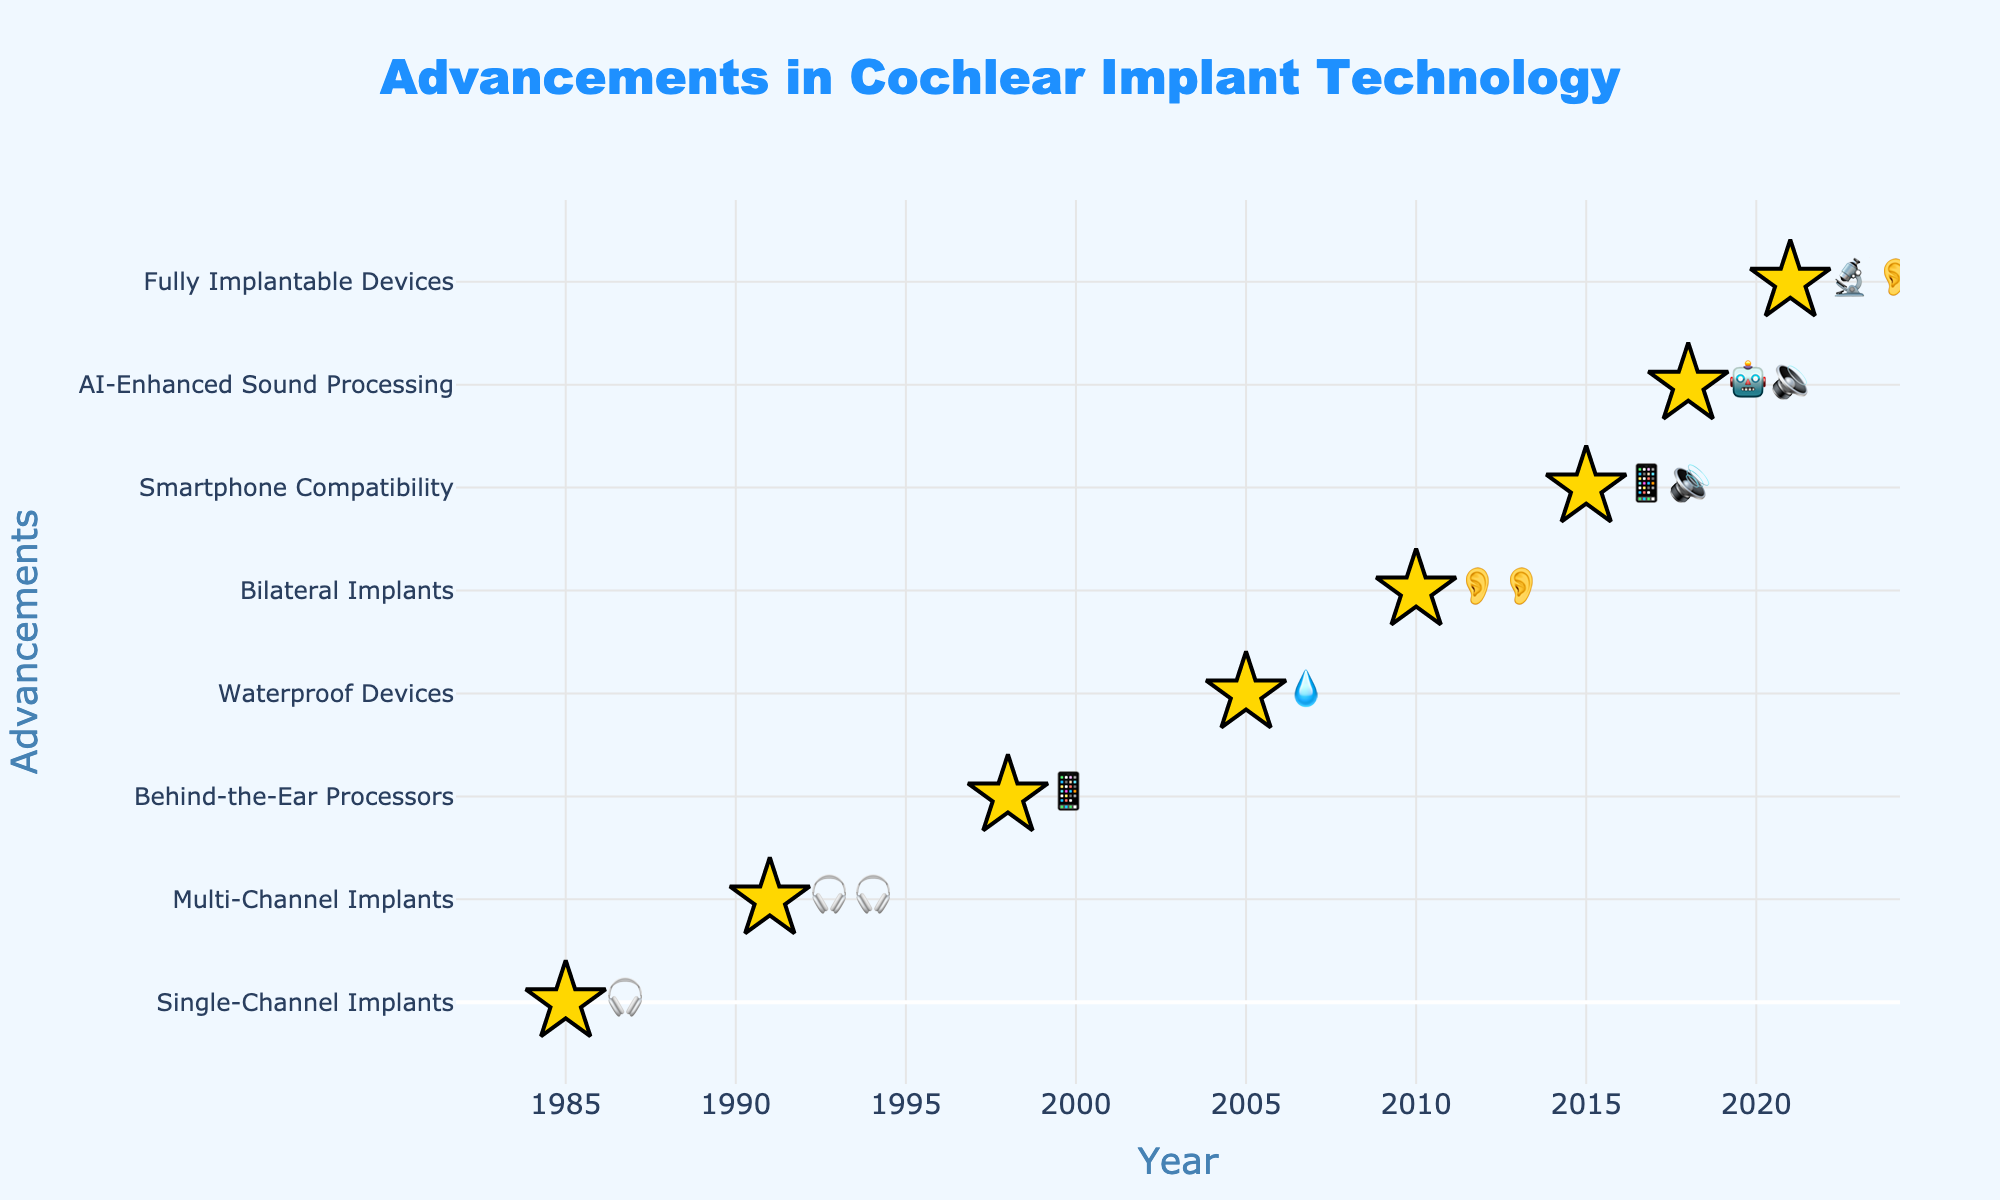How many advancements are shown in the figure? Count the number of markers, each representing an advancement. There are 8 markers, one for each row of data.
Answer: 8 What is the title of the figure? Look at the title text displayed at the top of the figure. It reads "Advancements in Cochlear Implant Technology".
Answer: Advancements in Cochlear Implant Technology Which year marked the introduction of Waterproof Devices? Identify the marker labeled "💧" representing Waterproof Devices and check its corresponding year, which is 2005.
Answer: 2005 What is the improvement symbol represented in the year 2018? Locate the year 2018 on the x-axis and check the improvement symbol next to it, which is "🤖🔉".
Answer: 🤖🔉 What are the two symbols introduced in 2015? Find the improvement symbols for the year 2015, which are next to the marker for that year. They are "📱🔊".
Answer: 📱🔊 Which advancement was introduced first, and what year was it? Identify the earliest year on the x-axis, which is 1985, and check the corresponding advancement, which is "Single-Channel Implants".
Answer: Single-Channel Implants, 1985 How many advancements occurred after the year 2000? Count the number of markers beyond the year 2000 on the x-axis. There are 5 advancements (2005, 2010, 2015, 2018, and 2021).
Answer: 5 Which two advancements involve using ears, based on their emoji? Look at the emoji symbols and identify the ones with ear symbols "👂👂" for Bilateral Implants (2010) and "🔬👂" for Fully Implantable Devices (2021).
Answer: Bilateral Implants, Fully Implantable Devices How many stars are used as markers on the plot? Count the number of star markers used in the scatter plot. Each data point is marked by one star, and there are 8 data points.
Answer: 8 Compare the advancements introduced in 1991 and 2015. Which one has more components in its improvement emoji? Check the improvement symbols for 1991 (🎧🎧) and 2015 (📱🔊). 2015 has two distinct symbols, while 1991 has two of the same.
Answer: 2015 